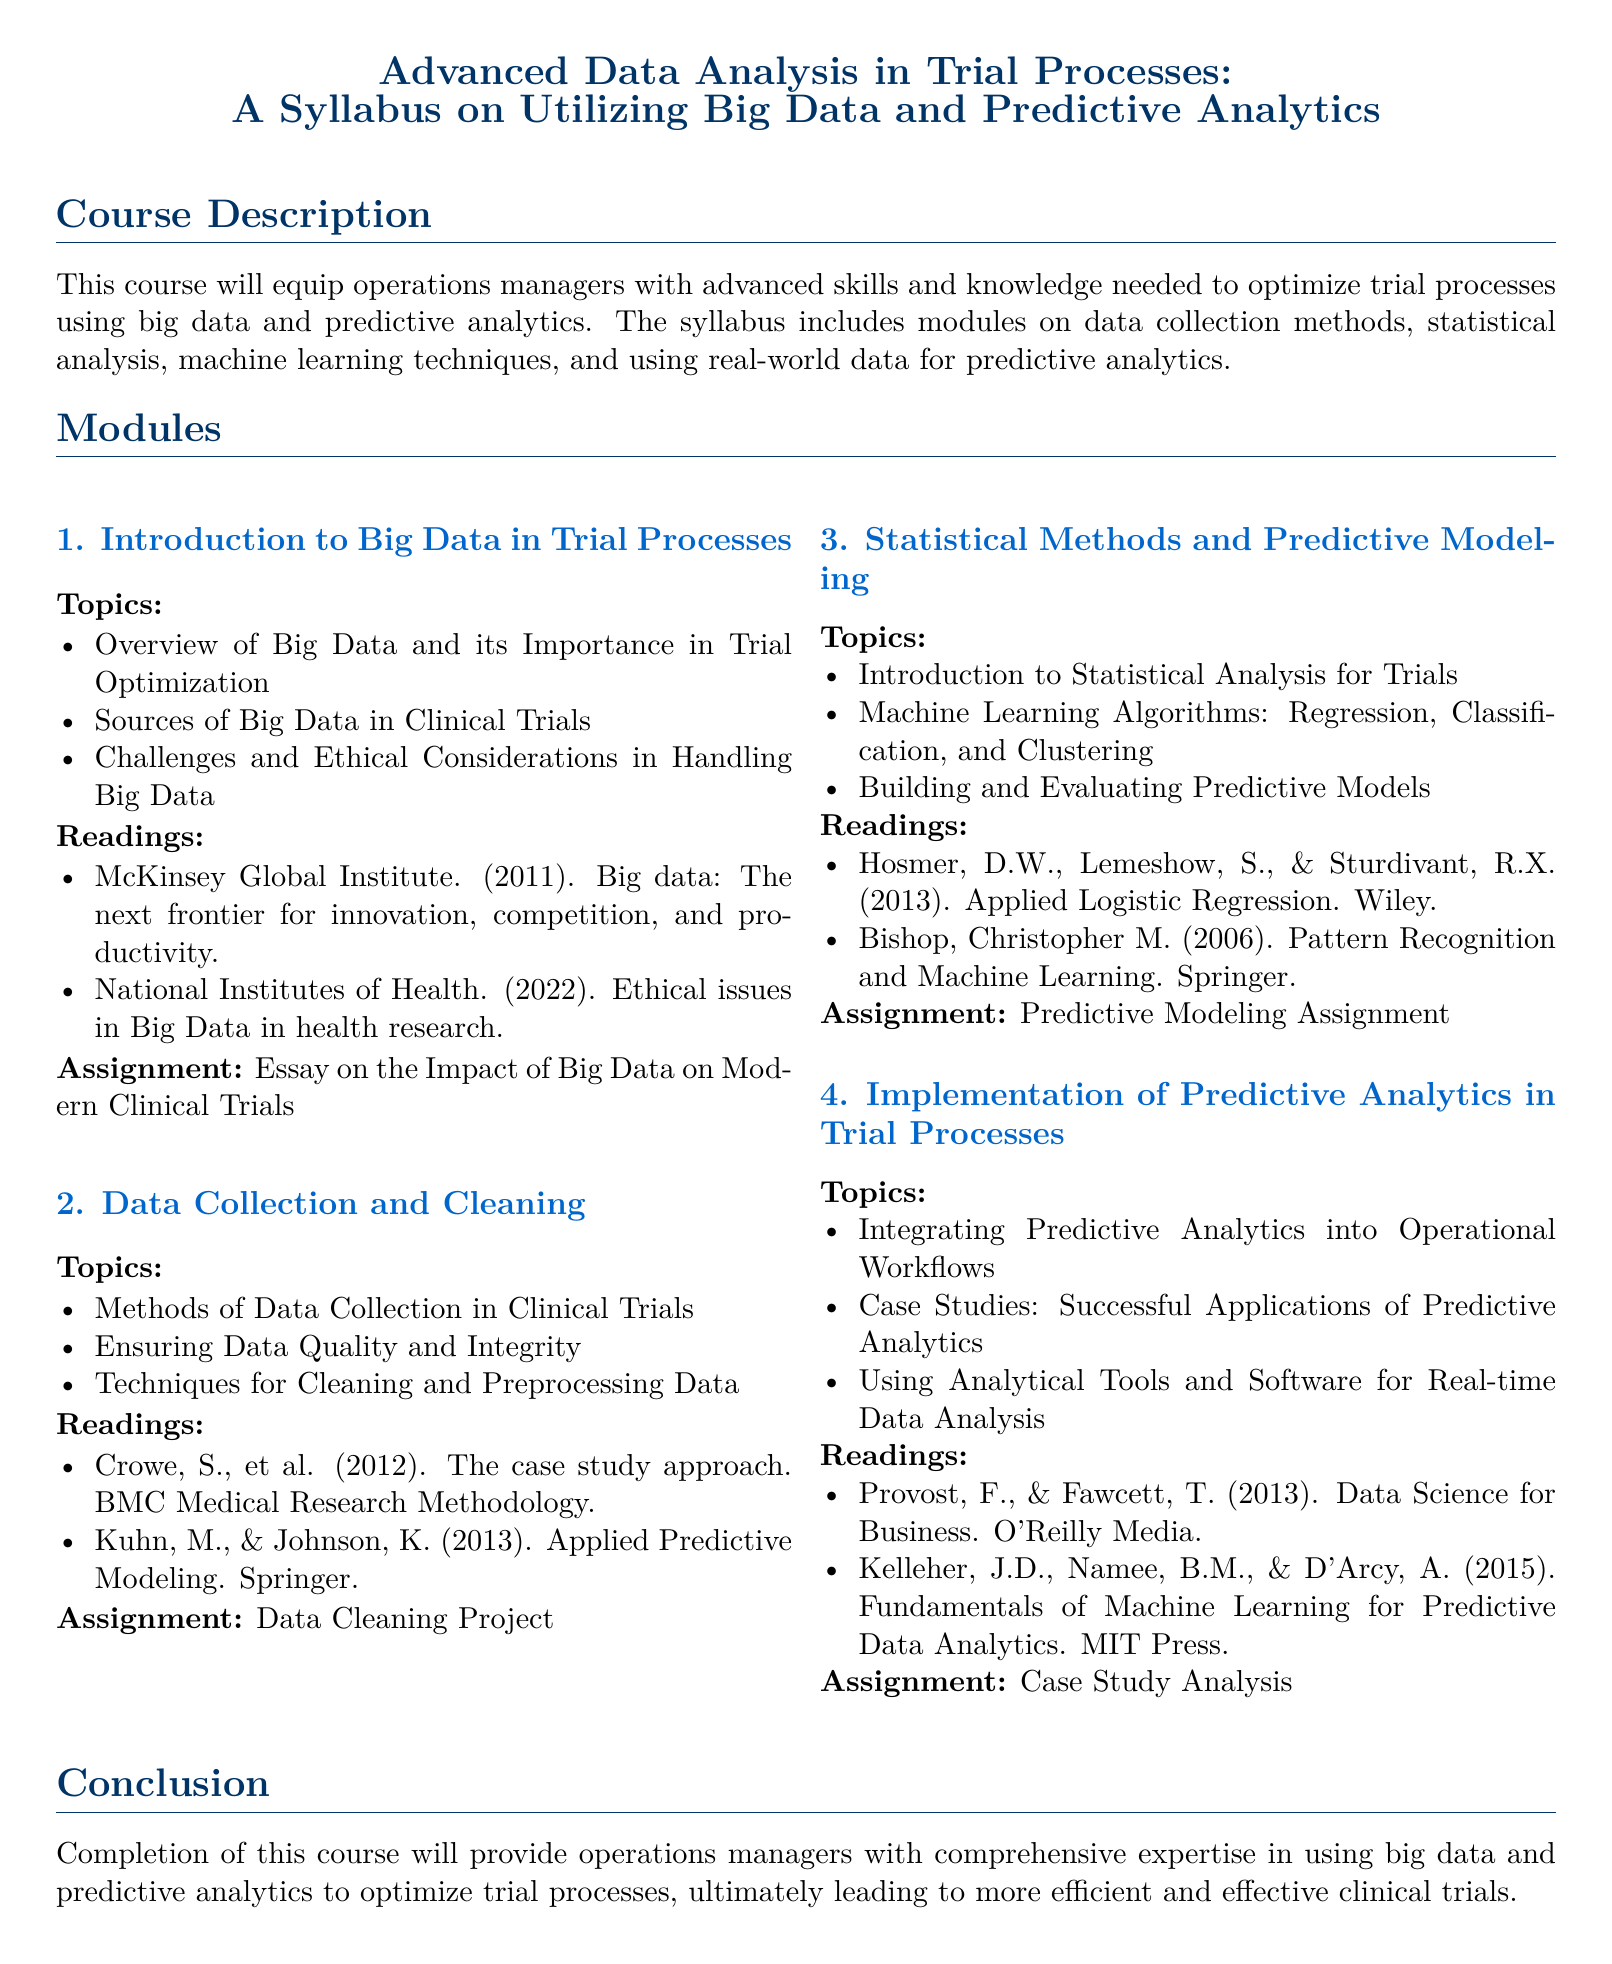what is the title of the course? The title of the course as presented in the syllabus is "Advanced Data Analysis in Trial Processes: A Syllabus on Utilizing Big Data and Predictive Analytics."
Answer: Advanced Data Analysis in Trial Processes: A Syllabus on Utilizing Big Data and Predictive Analytics how many modules are in the syllabus? The syllabus lists a total of four modules outlined for the course.
Answer: 4 what is the first topic covered in the first module? The first module introduces Big Data and its importance, with the first topic being "Overview of Big Data and its Importance in Trial Optimization."
Answer: Overview of Big Data and its Importance in Trial Optimization which book is assigned reading for the third module? The assigned reading for the third module includes "Applied Logistic Regression" by Hosmer, Lemeshow, and Sturdivant.
Answer: Applied Logistic Regression what is the final assignment listed in the syllabus? The final assignment outlined in the syllabus is a Case Study Analysis.
Answer: Case Study Analysis which ethical topic is mentioned in the first module's readings? An ethical issue in the first module's readings is "Ethical issues in Big Data in health research."
Answer: Ethical issues in Big Data in health research name one machine learning algorithm introduced in the third module. The third module introduces several algorithms, one of which is Regression.
Answer: Regression what is the purpose of the course as mentioned in the syllabus? The course's purpose is to equip operations managers with advanced skills for optimizing trial processes using big data and predictive analytics.
Answer: Equip operations managers with advanced skills for optimizing trial processes using big data and predictive analytics 